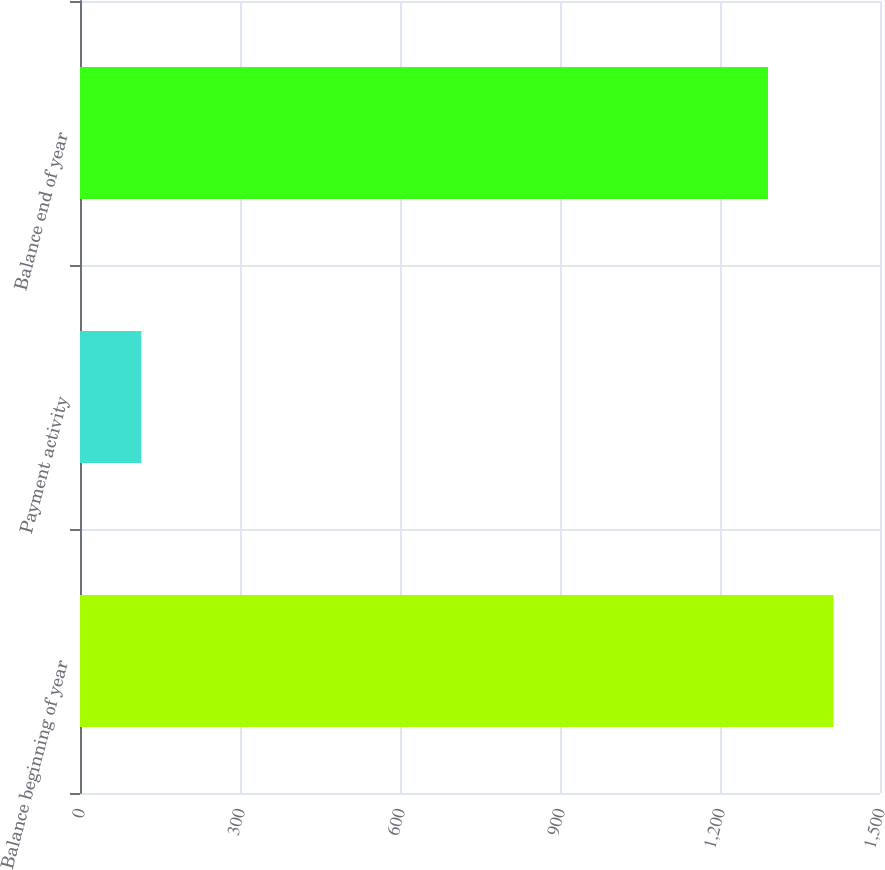<chart> <loc_0><loc_0><loc_500><loc_500><bar_chart><fcel>Balance beginning of year<fcel>Payment activity<fcel>Balance end of year<nl><fcel>1412.9<fcel>115<fcel>1290<nl></chart> 